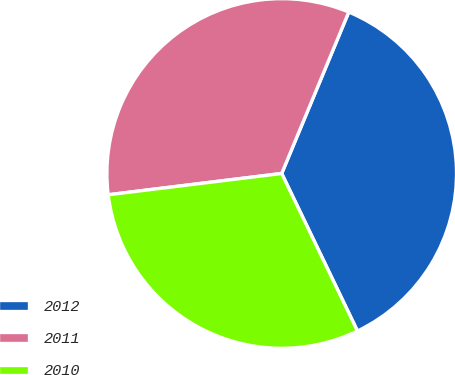Convert chart. <chart><loc_0><loc_0><loc_500><loc_500><pie_chart><fcel>2012<fcel>2011<fcel>2010<nl><fcel>36.6%<fcel>33.21%<fcel>30.19%<nl></chart> 